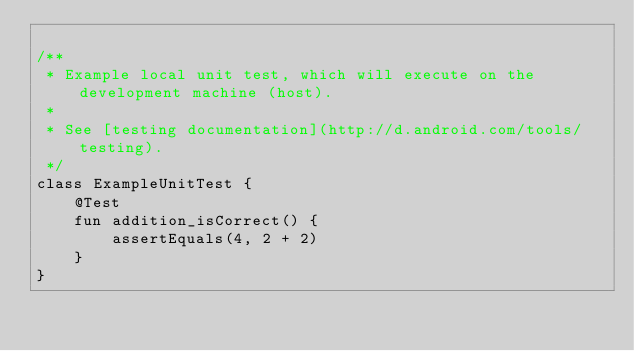<code> <loc_0><loc_0><loc_500><loc_500><_Kotlin_>
/**
 * Example local unit test, which will execute on the development machine (host).
 *
 * See [testing documentation](http://d.android.com/tools/testing).
 */
class ExampleUnitTest {
    @Test
    fun addition_isCorrect() {
        assertEquals(4, 2 + 2)
    }
}</code> 